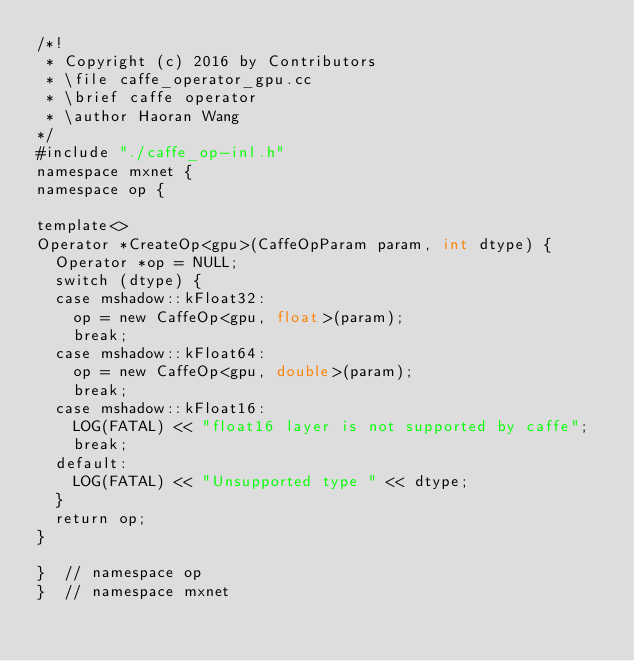Convert code to text. <code><loc_0><loc_0><loc_500><loc_500><_Cuda_>/*!
 * Copyright (c) 2016 by Contributors
 * \file caffe_operator_gpu.cc
 * \brief caffe operator
 * \author Haoran Wang
*/
#include "./caffe_op-inl.h"
namespace mxnet {
namespace op {

template<>
Operator *CreateOp<gpu>(CaffeOpParam param, int dtype) {
  Operator *op = NULL;
  switch (dtype) {
  case mshadow::kFloat32:
    op = new CaffeOp<gpu, float>(param);
    break;
  case mshadow::kFloat64:
    op = new CaffeOp<gpu, double>(param);
    break;
  case mshadow::kFloat16:
    LOG(FATAL) << "float16 layer is not supported by caffe";
    break;
  default:
    LOG(FATAL) << "Unsupported type " << dtype;
  }
  return op;
}

}  // namespace op
}  // namespace mxnet
</code> 